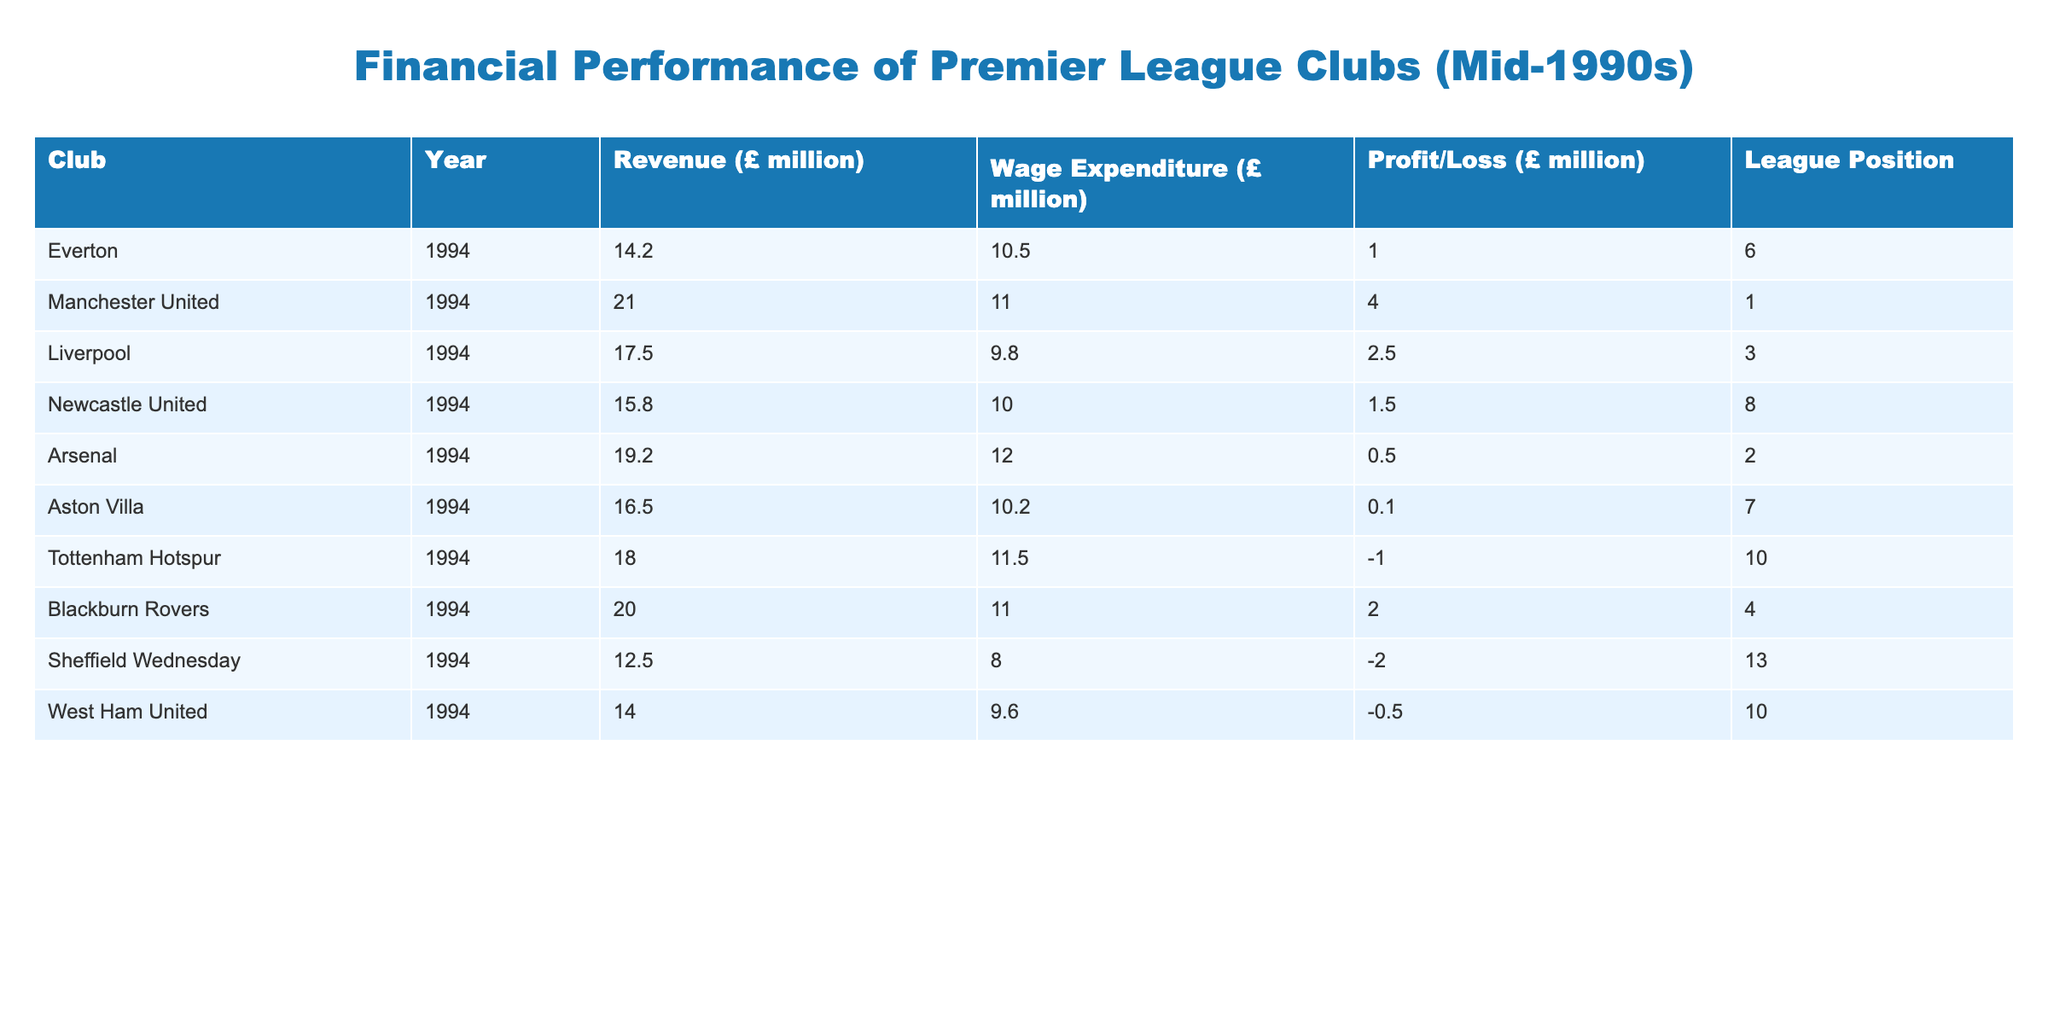What was the revenue of Everton in 1994? The table lists Everton's revenue for 1994 as £14.2 million.
Answer: £14.2 million Which club had the highest wage expenditure in 1994? By examining the wage expenditure column, Manchester United had the highest at £11.0 million.
Answer: Manchester United What is the total profit/loss for all clubs in 1994 combined? Adding the profit/loss values for all clubs: (1.0 + 4.0 + 2.5 + 1.5 + 0.5 + 0.1 + (-1.0) + 2.0 + (-2.0) + (-0.5)) = 7.6 million.
Answer: £7.6 million Did any club report a loss in 1994? Yes, Tottenham Hotspur, Sheffield Wednesday, and West Ham United reported losses based on their profit/loss figures.
Answer: Yes What is the average revenue of the Premier League clubs listed in the table for 1994? To find the average, sum the revenues (£14.2 + 21.0 + 17.5 + 15.8 + 19.2 + 16.5 + 18.0 + 20.0 + 12.5 + 14.0) =  154.7 million, then divide by the number of clubs (10), resulting in an average of £15.47 million.
Answer: £15.47 million How many clubs had profits greater than £2 million in 1994? Only Manchester United (£4.0 million) and Liverpool (£2.5 million) had profits greater than £2 million, totaling 2 clubs.
Answer: 2 clubs Which club had the lowest league position among those with a profit? The club with a profit but the lowest league position is Blackburn Rovers, ranked 4th with a profit of £2.0 million.
Answer: Blackburn Rovers What was the profit margin for Arsenal in 1994? Arsenal's profit margin is calculated as (Profit / Revenue) = (0.5 / 19.2) * 100 = approximately 2.60%.
Answer: 2.60% Which club had the lowest revenue in 1994? The club with the lowest revenue listed is Sheffield Wednesday, with revenue of £12.5 million.
Answer: Sheffield Wednesday 